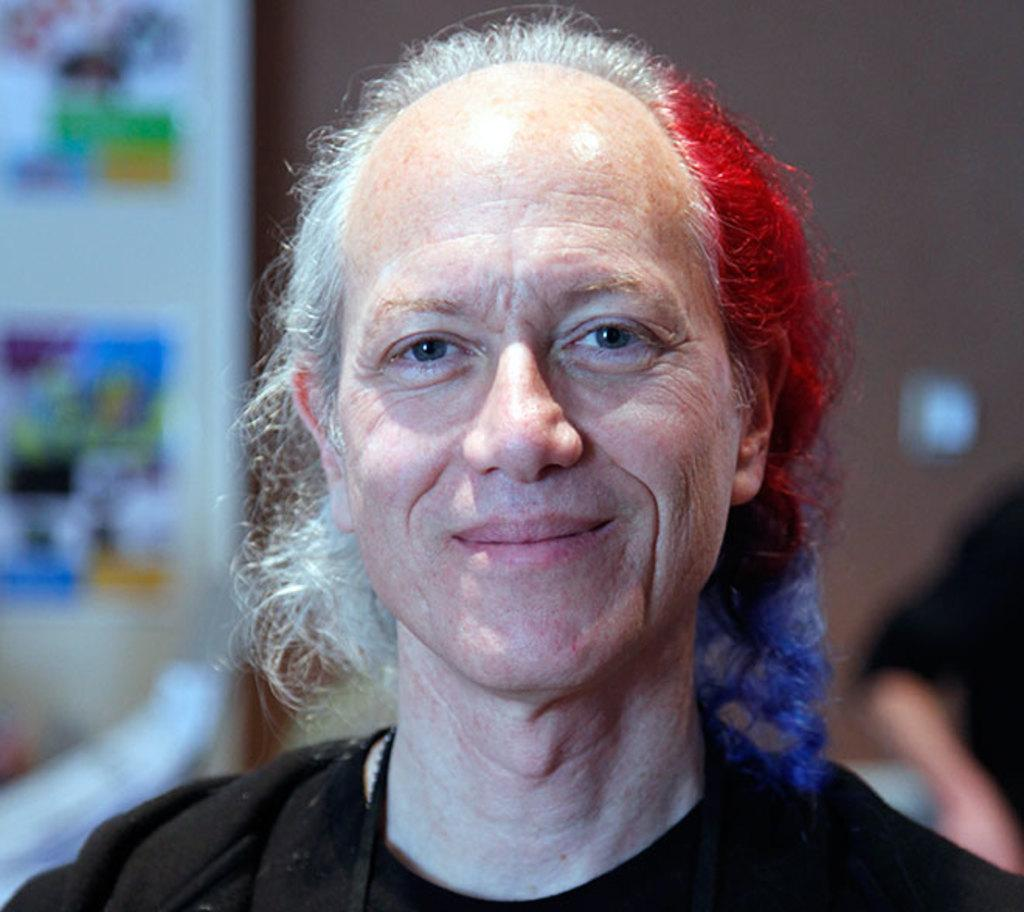Who is present in the image? There is a person in the image. What is the person wearing? The person is wearing a black dress. What can be observed about the person's hair? The person's hair is multicolored. Can you describe the background of the image? The background of the image is blurred. How many fairies are present in the image? There are no fairies present in the image; it features a person wearing a black dress with multicolored hair. What is the temperature of the boys in the image? There are no boys present in the image, so it is not possible to determine their temperature. 